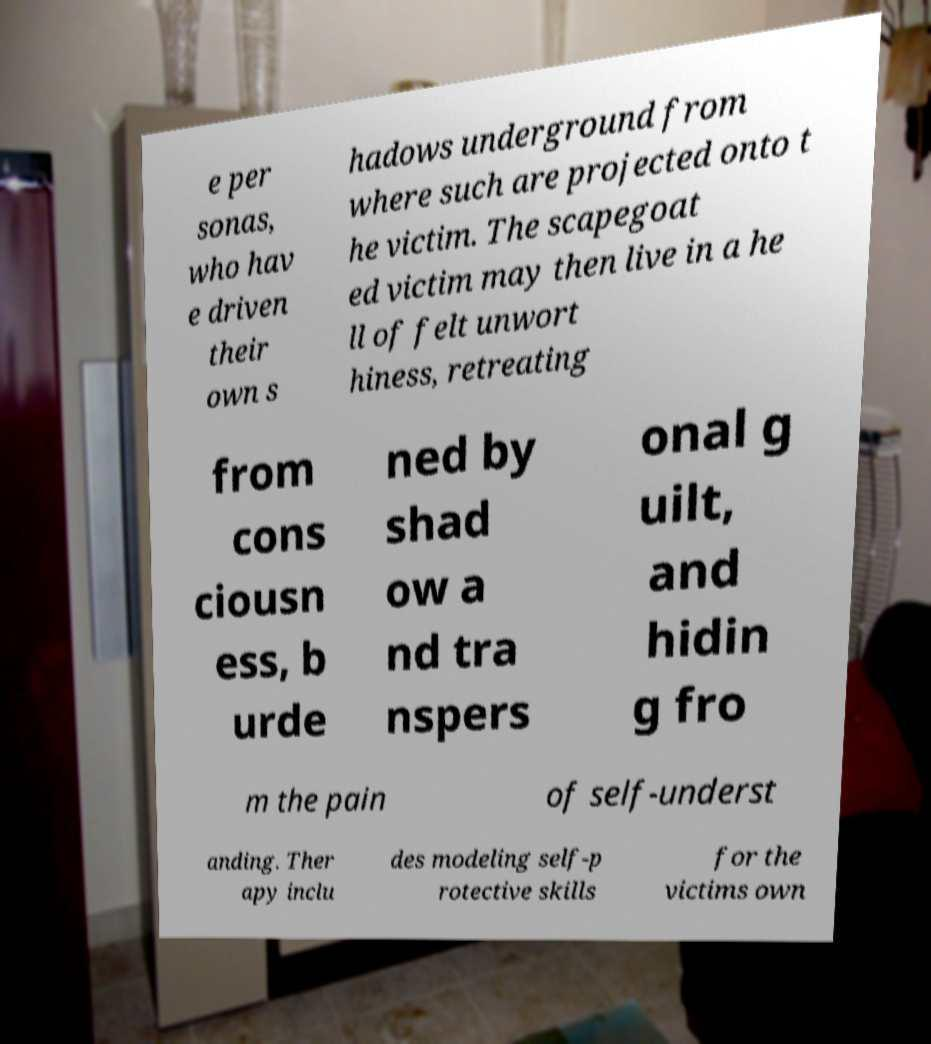Can you accurately transcribe the text from the provided image for me? e per sonas, who hav e driven their own s hadows underground from where such are projected onto t he victim. The scapegoat ed victim may then live in a he ll of felt unwort hiness, retreating from cons ciousn ess, b urde ned by shad ow a nd tra nspers onal g uilt, and hidin g fro m the pain of self-underst anding. Ther apy inclu des modeling self-p rotective skills for the victims own 